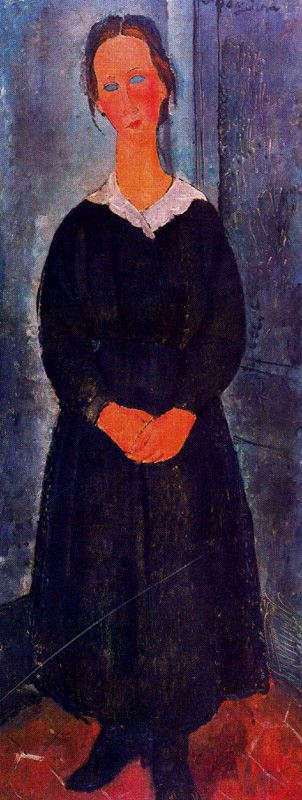What might the red color of the floor signify in this painting? The red floor in the painting could symbolize a range of emotions or themes, such as passion, vitality, or even turmoil. In contrast to the overall subdued palette of the room and her attire, the floor's bold color might represent underlying emotional intensity or a significant aspect of the woman's life that is not immediately visible. 